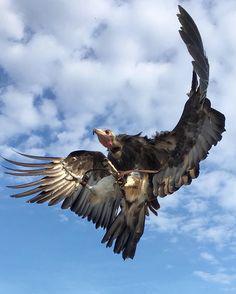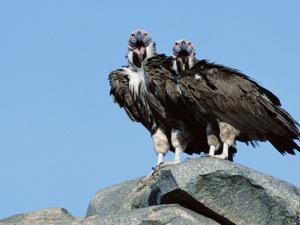The first image is the image on the left, the second image is the image on the right. Given the left and right images, does the statement "Two birds are close up, while 4 or more birds are flying high in the distance." hold true? Answer yes or no. No. The first image is the image on the left, the second image is the image on the right. Considering the images on both sides, is "A rear-facing vulture is perched on something wooden and has its wings spreading." valid? Answer yes or no. No. 